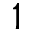Convert formula to latex. <formula><loc_0><loc_0><loc_500><loc_500>1</formula> 